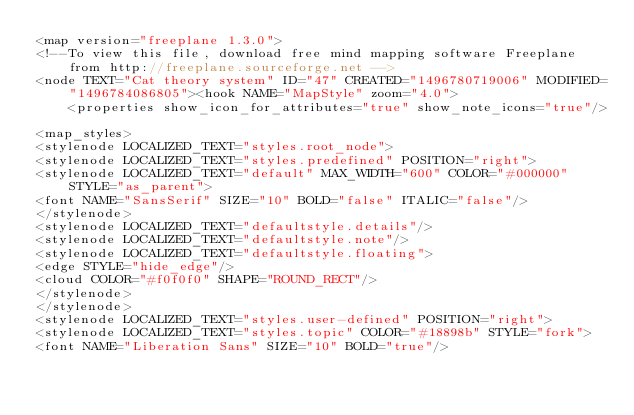<code> <loc_0><loc_0><loc_500><loc_500><_ObjectiveC_><map version="freeplane 1.3.0">
<!--To view this file, download free mind mapping software Freeplane from http://freeplane.sourceforge.net -->
<node TEXT="Cat theory system" ID="47" CREATED="1496780719006" MODIFIED="1496784086805"><hook NAME="MapStyle" zoom="4.0">
    <properties show_icon_for_attributes="true" show_note_icons="true"/>

<map_styles>
<stylenode LOCALIZED_TEXT="styles.root_node">
<stylenode LOCALIZED_TEXT="styles.predefined" POSITION="right">
<stylenode LOCALIZED_TEXT="default" MAX_WIDTH="600" COLOR="#000000" STYLE="as_parent">
<font NAME="SansSerif" SIZE="10" BOLD="false" ITALIC="false"/>
</stylenode>
<stylenode LOCALIZED_TEXT="defaultstyle.details"/>
<stylenode LOCALIZED_TEXT="defaultstyle.note"/>
<stylenode LOCALIZED_TEXT="defaultstyle.floating">
<edge STYLE="hide_edge"/>
<cloud COLOR="#f0f0f0" SHAPE="ROUND_RECT"/>
</stylenode>
</stylenode>
<stylenode LOCALIZED_TEXT="styles.user-defined" POSITION="right">
<stylenode LOCALIZED_TEXT="styles.topic" COLOR="#18898b" STYLE="fork">
<font NAME="Liberation Sans" SIZE="10" BOLD="true"/></code> 